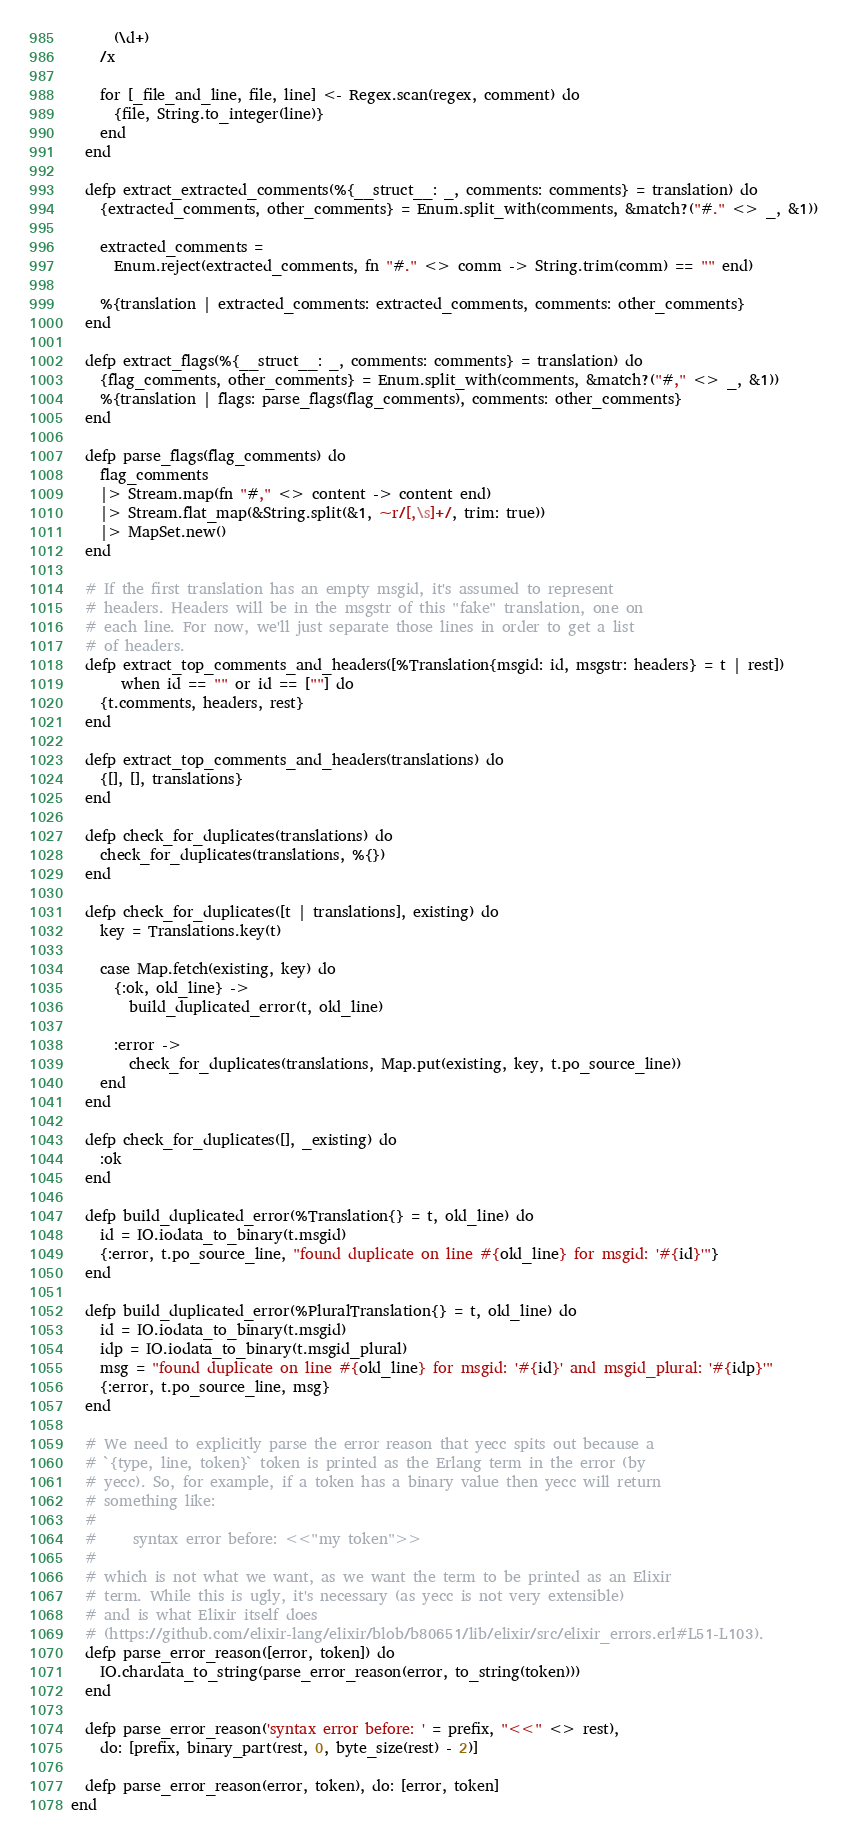<code> <loc_0><loc_0><loc_500><loc_500><_Elixir_>      (\d+)
    /x

    for [_file_and_line, file, line] <- Regex.scan(regex, comment) do
      {file, String.to_integer(line)}
    end
  end

  defp extract_extracted_comments(%{__struct__: _, comments: comments} = translation) do
    {extracted_comments, other_comments} = Enum.split_with(comments, &match?("#." <> _, &1))

    extracted_comments =
      Enum.reject(extracted_comments, fn "#." <> comm -> String.trim(comm) == "" end)

    %{translation | extracted_comments: extracted_comments, comments: other_comments}
  end

  defp extract_flags(%{__struct__: _, comments: comments} = translation) do
    {flag_comments, other_comments} = Enum.split_with(comments, &match?("#," <> _, &1))
    %{translation | flags: parse_flags(flag_comments), comments: other_comments}
  end

  defp parse_flags(flag_comments) do
    flag_comments
    |> Stream.map(fn "#," <> content -> content end)
    |> Stream.flat_map(&String.split(&1, ~r/[,\s]+/, trim: true))
    |> MapSet.new()
  end

  # If the first translation has an empty msgid, it's assumed to represent
  # headers. Headers will be in the msgstr of this "fake" translation, one on
  # each line. For now, we'll just separate those lines in order to get a list
  # of headers.
  defp extract_top_comments_and_headers([%Translation{msgid: id, msgstr: headers} = t | rest])
       when id == "" or id == [""] do
    {t.comments, headers, rest}
  end

  defp extract_top_comments_and_headers(translations) do
    {[], [], translations}
  end

  defp check_for_duplicates(translations) do
    check_for_duplicates(translations, %{})
  end

  defp check_for_duplicates([t | translations], existing) do
    key = Translations.key(t)

    case Map.fetch(existing, key) do
      {:ok, old_line} ->
        build_duplicated_error(t, old_line)

      :error ->
        check_for_duplicates(translations, Map.put(existing, key, t.po_source_line))
    end
  end

  defp check_for_duplicates([], _existing) do
    :ok
  end

  defp build_duplicated_error(%Translation{} = t, old_line) do
    id = IO.iodata_to_binary(t.msgid)
    {:error, t.po_source_line, "found duplicate on line #{old_line} for msgid: '#{id}'"}
  end

  defp build_duplicated_error(%PluralTranslation{} = t, old_line) do
    id = IO.iodata_to_binary(t.msgid)
    idp = IO.iodata_to_binary(t.msgid_plural)
    msg = "found duplicate on line #{old_line} for msgid: '#{id}' and msgid_plural: '#{idp}'"
    {:error, t.po_source_line, msg}
  end

  # We need to explicitly parse the error reason that yecc spits out because a
  # `{type, line, token}` token is printed as the Erlang term in the error (by
  # yecc). So, for example, if a token has a binary value then yecc will return
  # something like:
  #
  #     syntax error before: <<"my token">>
  #
  # which is not what we want, as we want the term to be printed as an Elixir
  # term. While this is ugly, it's necessary (as yecc is not very extensible)
  # and is what Elixir itself does
  # (https://github.com/elixir-lang/elixir/blob/b80651/lib/elixir/src/elixir_errors.erl#L51-L103).
  defp parse_error_reason([error, token]) do
    IO.chardata_to_string(parse_error_reason(error, to_string(token)))
  end

  defp parse_error_reason('syntax error before: ' = prefix, "<<" <> rest),
    do: [prefix, binary_part(rest, 0, byte_size(rest) - 2)]

  defp parse_error_reason(error, token), do: [error, token]
end
</code> 